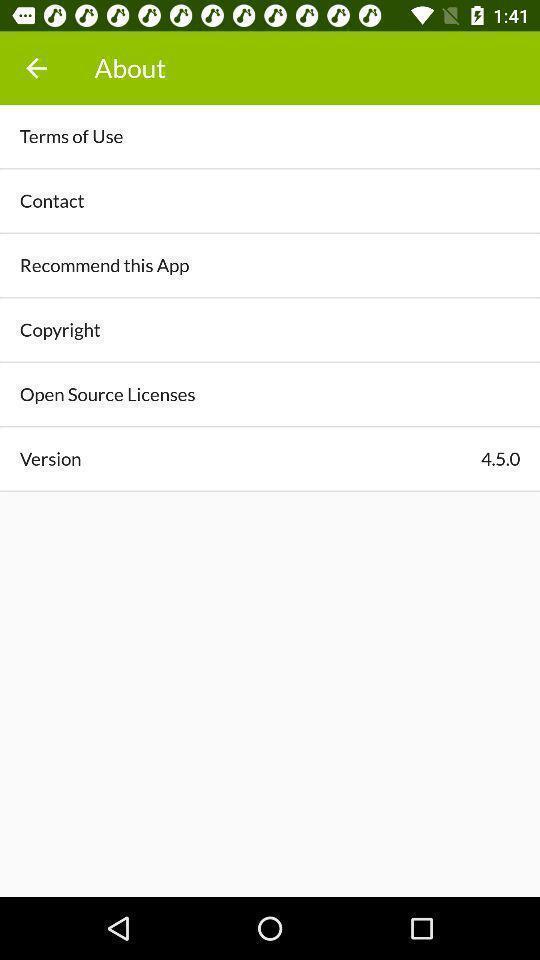What can you discern from this picture? Page showing the options in about tab. 